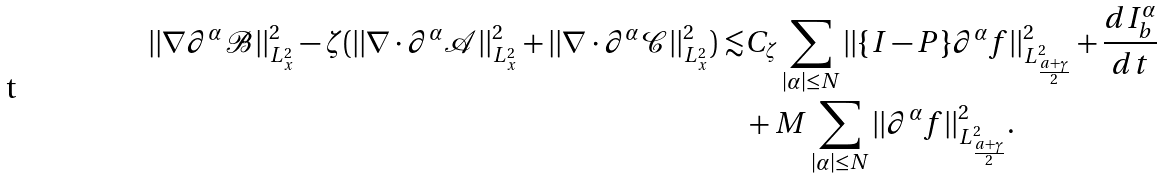<formula> <loc_0><loc_0><loc_500><loc_500>| | \nabla \partial ^ { \alpha } \mathcal { B } | | ^ { 2 } _ { L ^ { 2 } _ { x } } - \zeta ( | | \nabla \cdot \partial ^ { \alpha } \mathcal { A } | | ^ { 2 } _ { L ^ { 2 } _ { x } } + | | \nabla \cdot \partial ^ { \alpha } \mathcal { C } | | ^ { 2 } _ { L ^ { 2 } _ { x } } ) \lesssim & C _ { \zeta } \sum _ { | \alpha | \leq N } | | \{ I - P \} \partial ^ { \alpha } f | | ^ { 2 } _ { L ^ { 2 } _ { \frac { a + \gamma } { 2 } } } + \frac { d I ^ { \alpha } _ { b } } { d t } \\ & + M \sum _ { | \alpha | \leq N } | | \partial ^ { \alpha } f | | ^ { 2 } _ { L ^ { 2 } _ { \frac { a + \gamma } { 2 } } } .</formula> 